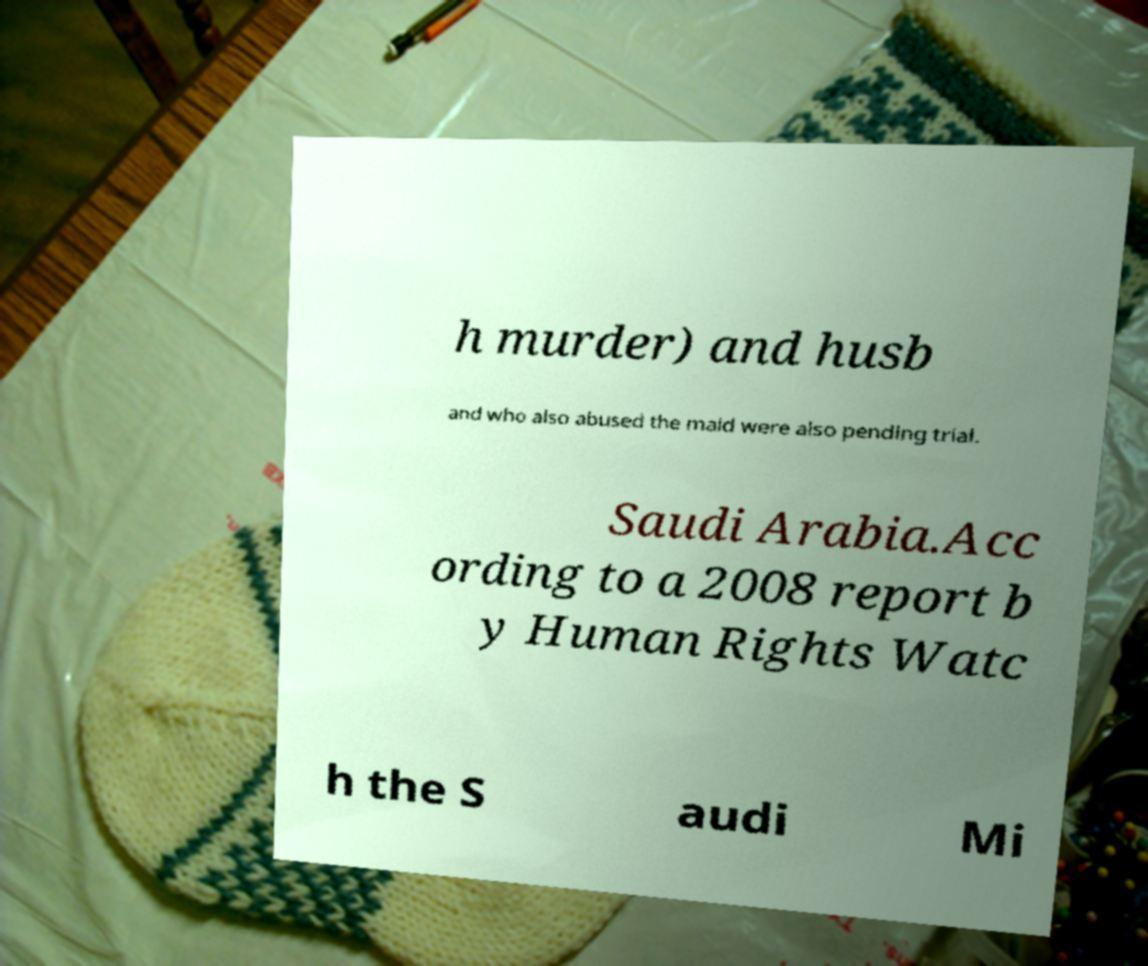Can you accurately transcribe the text from the provided image for me? h murder) and husb and who also abused the maid were also pending trial. Saudi Arabia.Acc ording to a 2008 report b y Human Rights Watc h the S audi Mi 